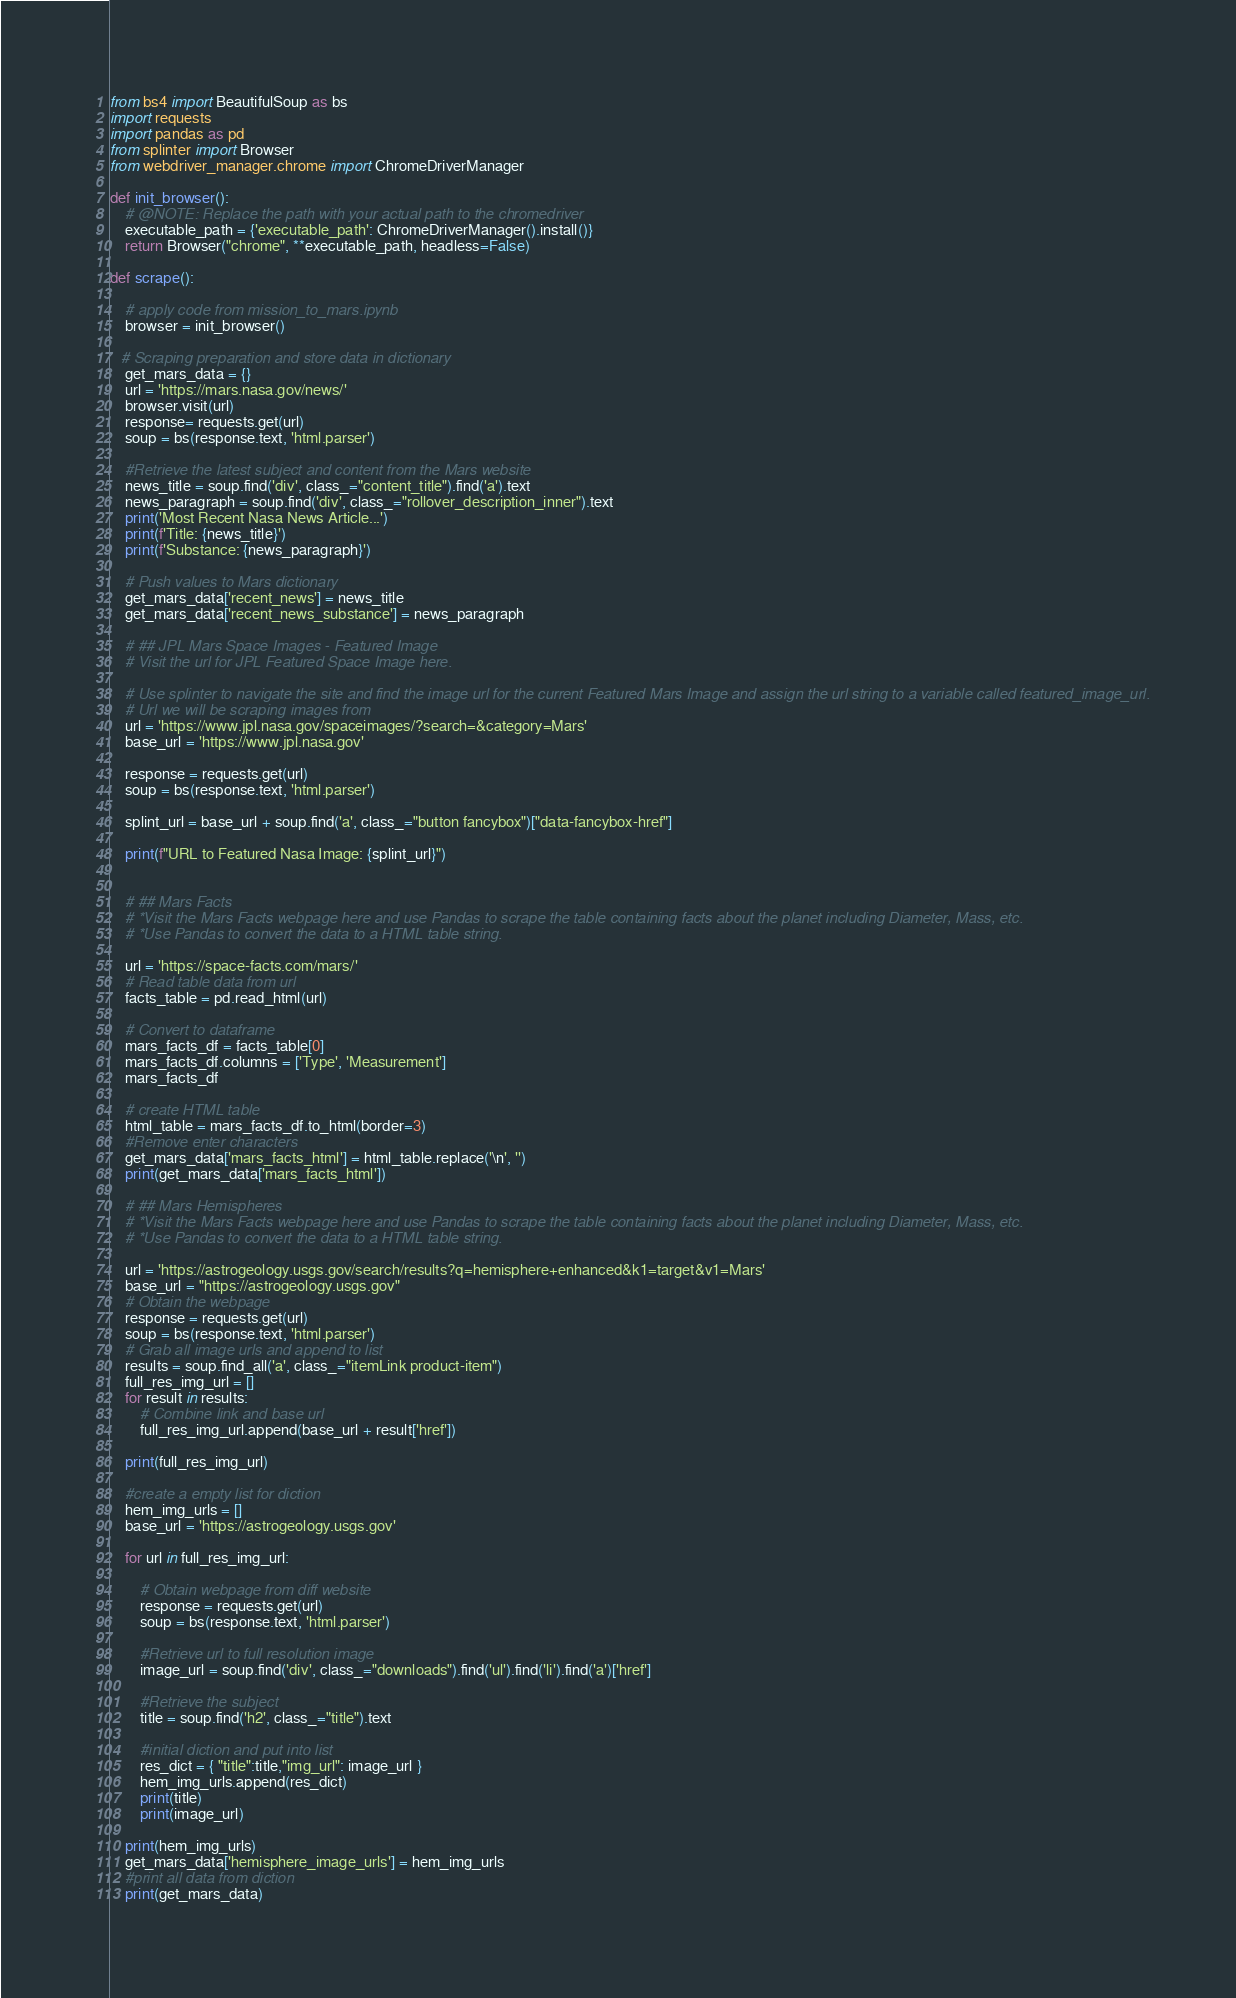Convert code to text. <code><loc_0><loc_0><loc_500><loc_500><_Python_>from bs4 import BeautifulSoup as bs
import requests
import pandas as pd
from splinter import Browser
from webdriver_manager.chrome import ChromeDriverManager

def init_browser():
    # @NOTE: Replace the path with your actual path to the chromedriver
    executable_path = {'executable_path': ChromeDriverManager().install()}
    return Browser("chrome", **executable_path, headless=False)

def scrape():

    # apply code from mission_to_mars.ipynb
    browser = init_browser()

   # Scraping preparation and store data in dictionary
    get_mars_data = {}
    url = 'https://mars.nasa.gov/news/'
    browser.visit(url)
    response= requests.get(url)
    soup = bs(response.text, 'html.parser')

    #Retrieve the latest subject and content from the Mars website
    news_title = soup.find('div', class_="content_title").find('a').text
    news_paragraph = soup.find('div', class_="rollover_description_inner").text
    print('Most Recent Nasa News Article...')
    print(f'Title: {news_title}')
    print(f'Substance: {news_paragraph}')

    # Push values to Mars dictionary
    get_mars_data['recent_news'] = news_title
    get_mars_data['recent_news_substance'] = news_paragraph

    # ## JPL Mars Space Images - Featured Image
    # Visit the url for JPL Featured Space Image here.

    # Use splinter to navigate the site and find the image url for the current Featured Mars Image and assign the url string to a variable called featured_image_url.
    # Url we will be scraping images from
    url = 'https://www.jpl.nasa.gov/spaceimages/?search=&category=Mars'
    base_url = 'https://www.jpl.nasa.gov'

    response = requests.get(url)
    soup = bs(response.text, 'html.parser')

    splint_url = base_url + soup.find('a', class_="button fancybox")["data-fancybox-href"]

    print(f"URL to Featured Nasa Image: {splint_url}")


    # ## Mars Facts
    # *Visit the Mars Facts webpage here and use Pandas to scrape the table containing facts about the planet including Diameter, Mass, etc.
    # *Use Pandas to convert the data to a HTML table string.

    url = 'https://space-facts.com/mars/'
    # Read table data from url
    facts_table = pd.read_html(url)

    # Convert to dataframe
    mars_facts_df = facts_table[0]
    mars_facts_df.columns = ['Type', 'Measurement']
    mars_facts_df

    # create HTML table
    html_table = mars_facts_df.to_html(border=3)
    #Remove enter characters 
    get_mars_data['mars_facts_html'] = html_table.replace('\n', '')
    print(get_mars_data['mars_facts_html'])

    # ## Mars Hemispheres
    # *Visit the Mars Facts webpage here and use Pandas to scrape the table containing facts about the planet including Diameter, Mass, etc.
    # *Use Pandas to convert the data to a HTML table string.

    url = 'https://astrogeology.usgs.gov/search/results?q=hemisphere+enhanced&k1=target&v1=Mars'
    base_url = "https://astrogeology.usgs.gov"
    # Obtain the webpage
    response = requests.get(url)
    soup = bs(response.text, 'html.parser')
    # Grab all image urls and append to list
    results = soup.find_all('a', class_="itemLink product-item")
    full_res_img_url = []
    for result in results:
        # Combine link and base url
        full_res_img_url.append(base_url + result['href'])
    
    print(full_res_img_url)

    #create a empty list for diction
    hem_img_urls = []
    base_url = 'https://astrogeology.usgs.gov'

    for url in full_res_img_url:
    
        # Obtain webpage from diff website
        response = requests.get(url)
        soup = bs(response.text, 'html.parser')
    
        #Retrieve url to full resolution image
        image_url = soup.find('div', class_="downloads").find('ul').find('li').find('a')['href']
    
        #Retrieve the subject
        title = soup.find('h2', class_="title").text
    
        #initial diction and put into list
        res_dict = { "title":title,"img_url": image_url }
        hem_img_urls.append(res_dict)
        print(title)
        print(image_url)
    
    print(hem_img_urls)
    get_mars_data['hemisphere_image_urls'] = hem_img_urls
    #print all data from diction 
    print(get_mars_data)

</code> 